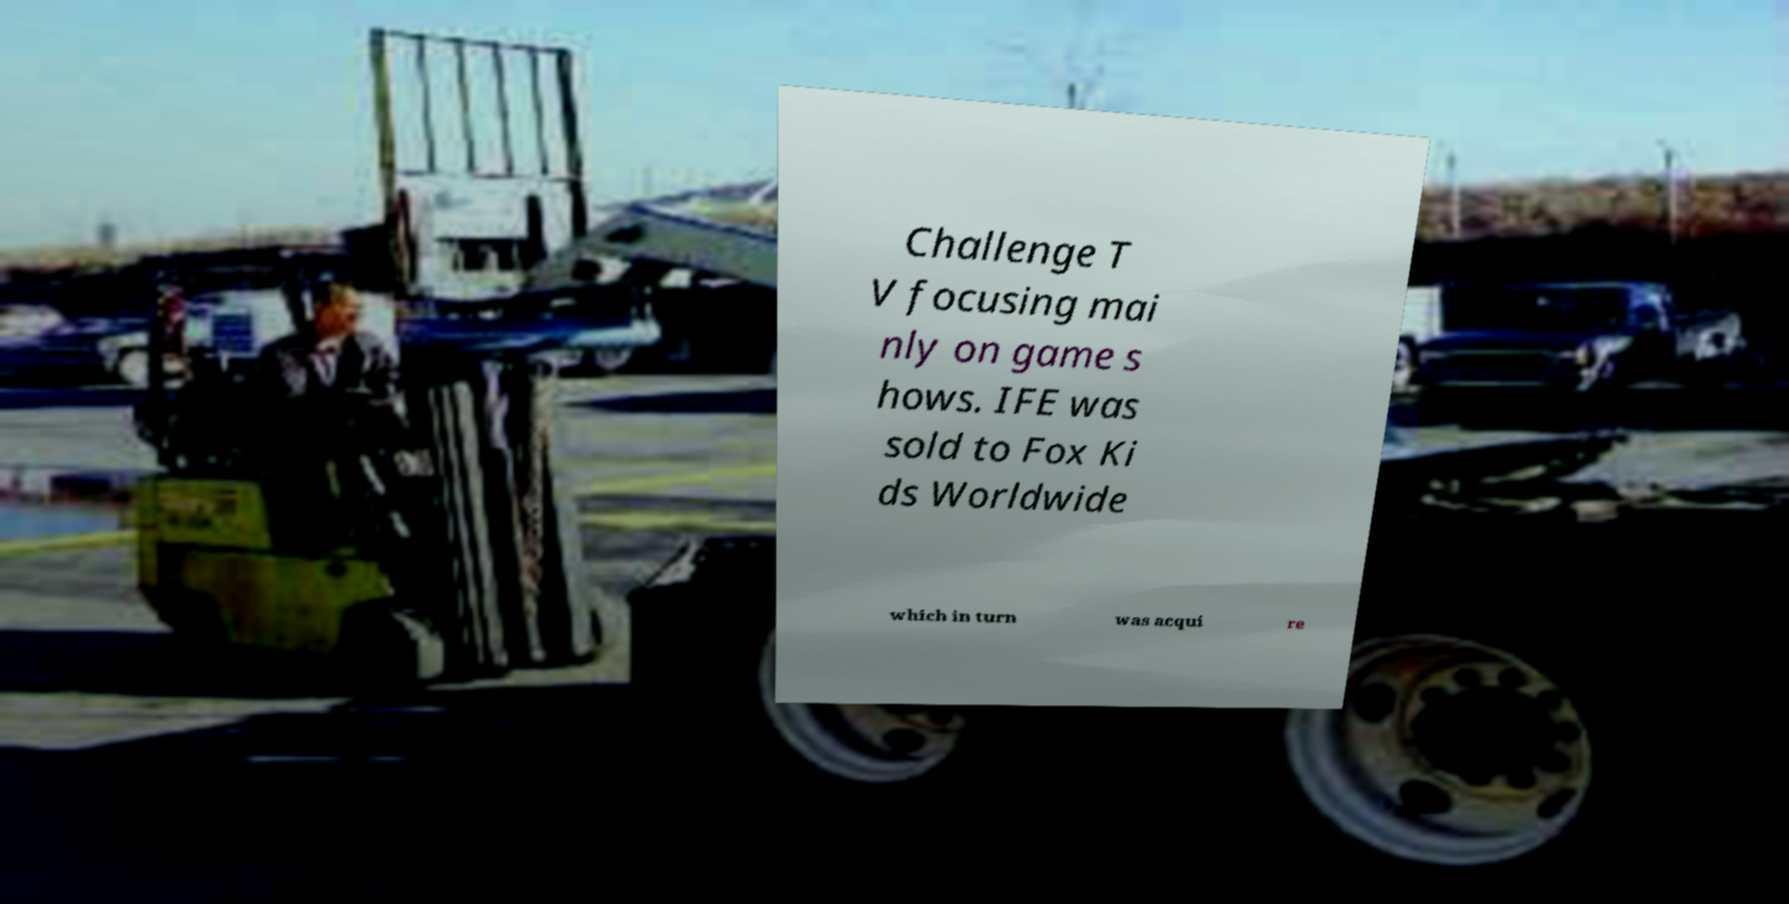Please identify and transcribe the text found in this image. Challenge T V focusing mai nly on game s hows. IFE was sold to Fox Ki ds Worldwide which in turn was acqui re 